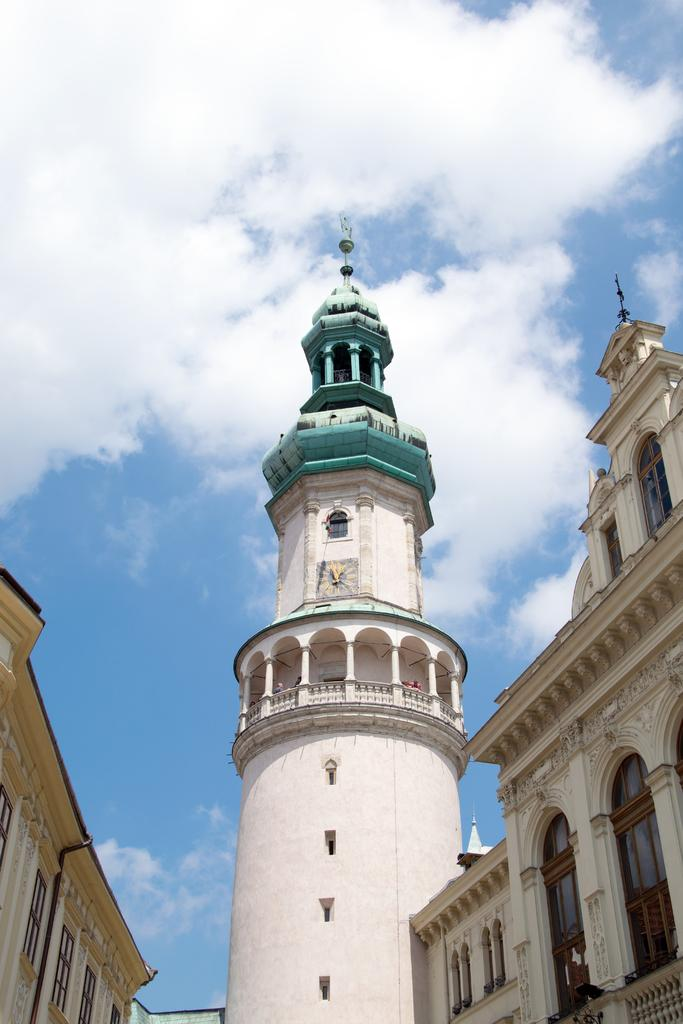What type of structures can be seen in the image? There are buildings in the image, including a tower-like building. Can you describe the tower-like building in the image? The tower-like building has a pole associated with it. What type of grain is being harvested near the tower-like building in the image? There is no grain or harvesting activity present in the image. 